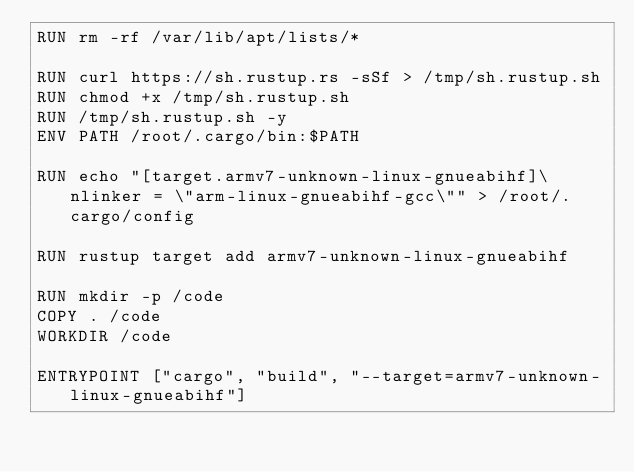<code> <loc_0><loc_0><loc_500><loc_500><_Dockerfile_>RUN rm -rf /var/lib/apt/lists/*

RUN curl https://sh.rustup.rs -sSf > /tmp/sh.rustup.sh
RUN chmod +x /tmp/sh.rustup.sh
RUN /tmp/sh.rustup.sh -y
ENV PATH /root/.cargo/bin:$PATH

RUN echo "[target.armv7-unknown-linux-gnueabihf]\nlinker = \"arm-linux-gnueabihf-gcc\"" > /root/.cargo/config

RUN rustup target add armv7-unknown-linux-gnueabihf

RUN mkdir -p /code
COPY . /code
WORKDIR /code

ENTRYPOINT ["cargo", "build", "--target=armv7-unknown-linux-gnueabihf"]
</code> 